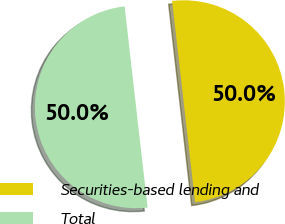<chart> <loc_0><loc_0><loc_500><loc_500><pie_chart><fcel>Securities-based lending and<fcel>Total<nl><fcel>50.0%<fcel>50.0%<nl></chart> 